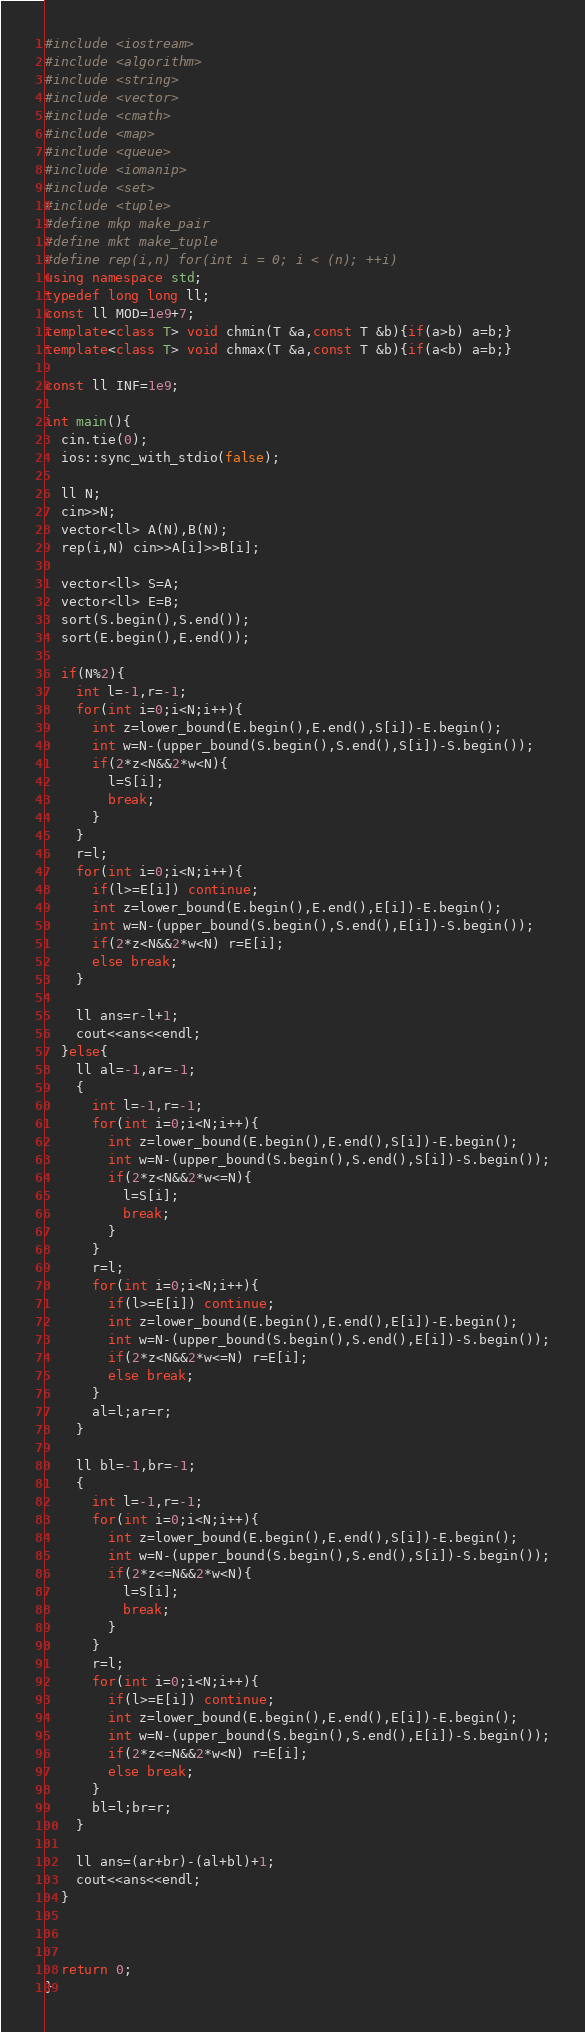<code> <loc_0><loc_0><loc_500><loc_500><_C++_>#include <iostream>
#include <algorithm>
#include <string>
#include <vector>
#include <cmath>
#include <map>
#include <queue>
#include <iomanip>
#include <set>
#include <tuple>
#define mkp make_pair
#define mkt make_tuple
#define rep(i,n) for(int i = 0; i < (n); ++i)
using namespace std;
typedef long long ll;
const ll MOD=1e9+7;
template<class T> void chmin(T &a,const T &b){if(a>b) a=b;}
template<class T> void chmax(T &a,const T &b){if(a<b) a=b;}

const ll INF=1e9;

int main(){
  cin.tie(0);
  ios::sync_with_stdio(false);

  ll N;
  cin>>N;
  vector<ll> A(N),B(N);
  rep(i,N) cin>>A[i]>>B[i];

  vector<ll> S=A;
  vector<ll> E=B;
  sort(S.begin(),S.end());
  sort(E.begin(),E.end());

  if(N%2){
    int l=-1,r=-1;
    for(int i=0;i<N;i++){
      int z=lower_bound(E.begin(),E.end(),S[i])-E.begin();
      int w=N-(upper_bound(S.begin(),S.end(),S[i])-S.begin());
      if(2*z<N&&2*w<N){
        l=S[i];
        break;
      }
    }
    r=l;
    for(int i=0;i<N;i++){
      if(l>=E[i]) continue;
      int z=lower_bound(E.begin(),E.end(),E[i])-E.begin();
      int w=N-(upper_bound(S.begin(),S.end(),E[i])-S.begin());
      if(2*z<N&&2*w<N) r=E[i];
      else break;
    }

    ll ans=r-l+1;
    cout<<ans<<endl;
  }else{
    ll al=-1,ar=-1;
    {
      int l=-1,r=-1;
      for(int i=0;i<N;i++){
        int z=lower_bound(E.begin(),E.end(),S[i])-E.begin();
        int w=N-(upper_bound(S.begin(),S.end(),S[i])-S.begin());
        if(2*z<N&&2*w<=N){
          l=S[i];
          break;
        }
      }
      r=l;
      for(int i=0;i<N;i++){
        if(l>=E[i]) continue;
        int z=lower_bound(E.begin(),E.end(),E[i])-E.begin();
        int w=N-(upper_bound(S.begin(),S.end(),E[i])-S.begin());
        if(2*z<N&&2*w<=N) r=E[i];
        else break;
      }
      al=l;ar=r;
    }

    ll bl=-1,br=-1;
    {
      int l=-1,r=-1;
      for(int i=0;i<N;i++){
        int z=lower_bound(E.begin(),E.end(),S[i])-E.begin();
        int w=N-(upper_bound(S.begin(),S.end(),S[i])-S.begin());
        if(2*z<=N&&2*w<N){
          l=S[i];
          break;
        }
      }
      r=l;
      for(int i=0;i<N;i++){
        if(l>=E[i]) continue;
        int z=lower_bound(E.begin(),E.end(),E[i])-E.begin();
        int w=N-(upper_bound(S.begin(),S.end(),E[i])-S.begin());
        if(2*z<=N&&2*w<N) r=E[i];
        else break;
      }
      bl=l;br=r;
    }

    ll ans=(ar+br)-(al+bl)+1;
    cout<<ans<<endl;
  }



  return 0;
}
</code> 